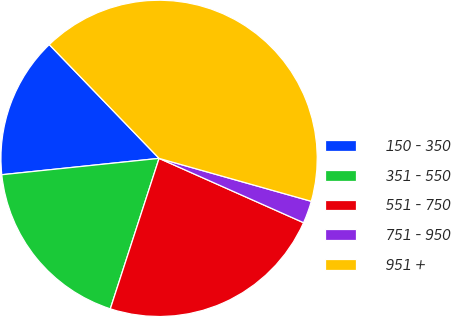Convert chart to OTSL. <chart><loc_0><loc_0><loc_500><loc_500><pie_chart><fcel>150 - 350<fcel>351 - 550<fcel>551 - 750<fcel>751 - 950<fcel>951 +<nl><fcel>14.43%<fcel>18.36%<fcel>23.32%<fcel>2.29%<fcel>41.59%<nl></chart> 